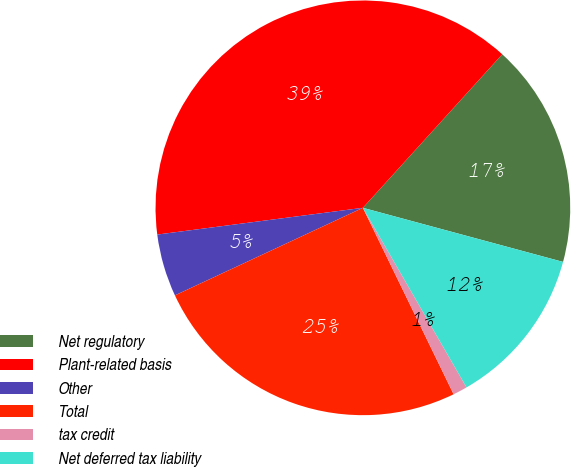Convert chart to OTSL. <chart><loc_0><loc_0><loc_500><loc_500><pie_chart><fcel>Net regulatory<fcel>Plant-related basis<fcel>Other<fcel>Total<fcel>tax credit<fcel>Net deferred tax liability<nl><fcel>17.47%<fcel>38.79%<fcel>4.88%<fcel>25.27%<fcel>1.12%<fcel>12.47%<nl></chart> 